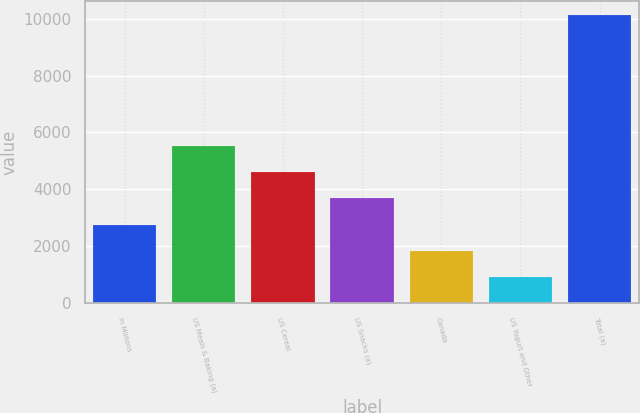<chart> <loc_0><loc_0><loc_500><loc_500><bar_chart><fcel>In Millions<fcel>US Meals & Baking (a)<fcel>US Cereal<fcel>US Snacks (a)<fcel>Canada<fcel>US Yogurt and Other<fcel>Total (a)<nl><fcel>2765<fcel>5521.4<fcel>4602.6<fcel>3683.8<fcel>1846.2<fcel>927.4<fcel>10115.4<nl></chart> 